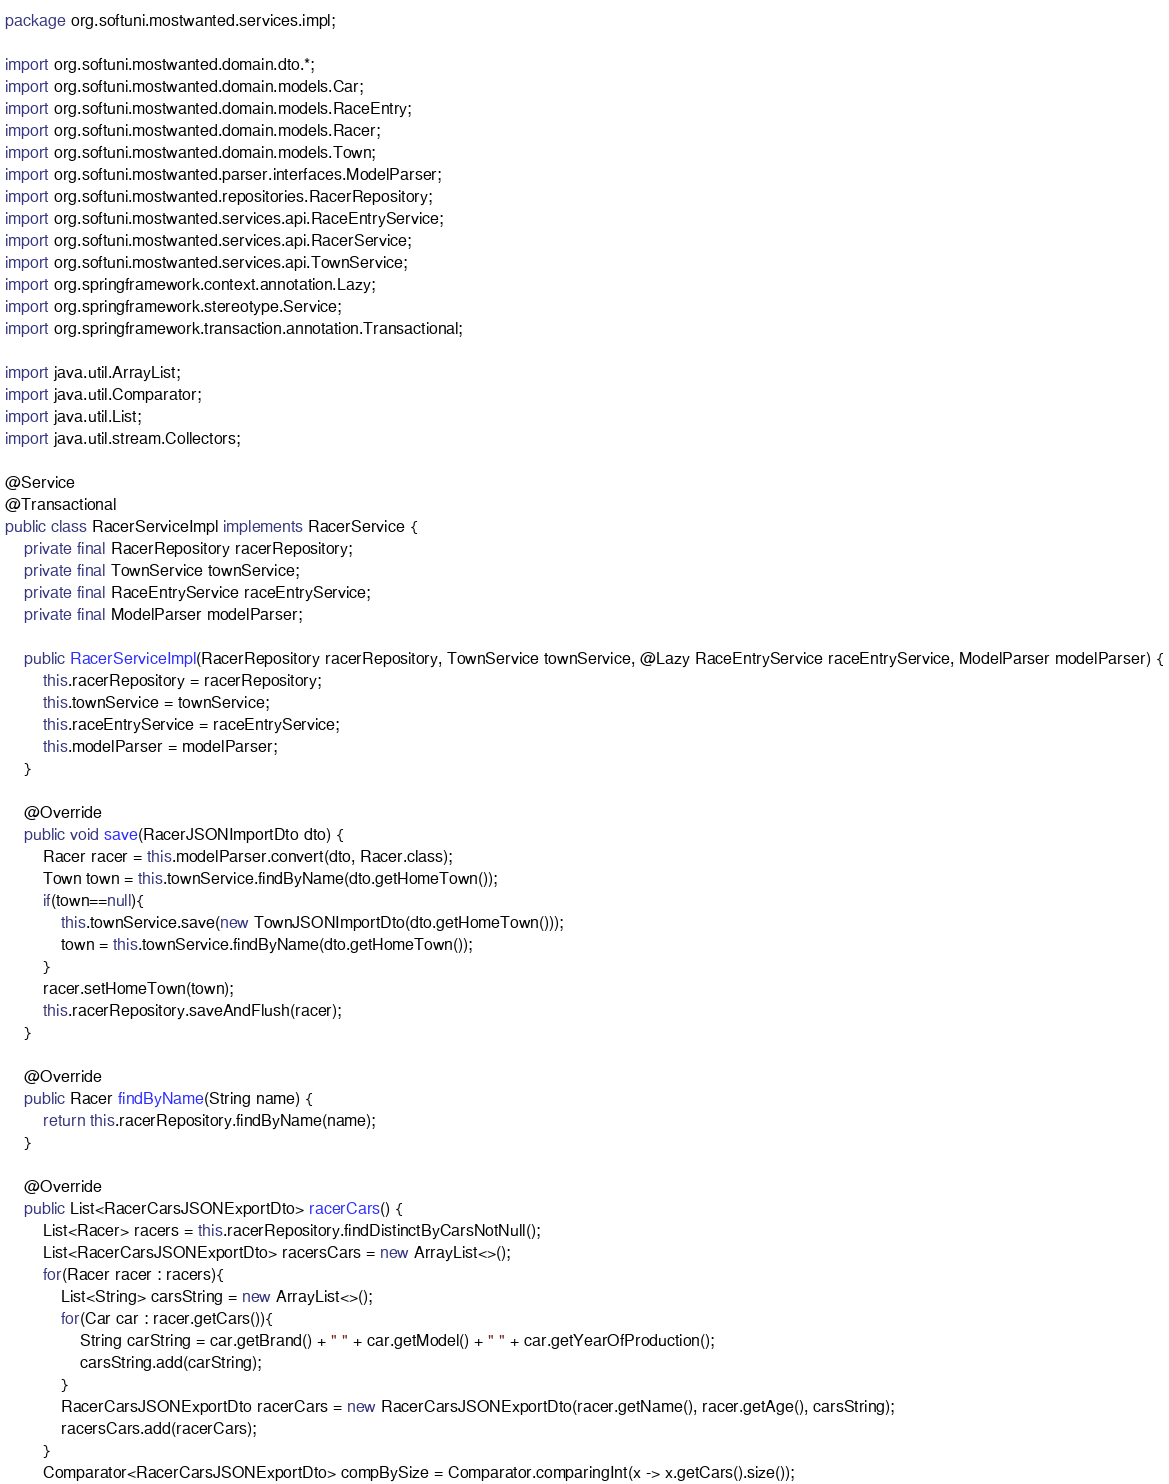<code> <loc_0><loc_0><loc_500><loc_500><_Java_>package org.softuni.mostwanted.services.impl;

import org.softuni.mostwanted.domain.dto.*;
import org.softuni.mostwanted.domain.models.Car;
import org.softuni.mostwanted.domain.models.RaceEntry;
import org.softuni.mostwanted.domain.models.Racer;
import org.softuni.mostwanted.domain.models.Town;
import org.softuni.mostwanted.parser.interfaces.ModelParser;
import org.softuni.mostwanted.repositories.RacerRepository;
import org.softuni.mostwanted.services.api.RaceEntryService;
import org.softuni.mostwanted.services.api.RacerService;
import org.softuni.mostwanted.services.api.TownService;
import org.springframework.context.annotation.Lazy;
import org.springframework.stereotype.Service;
import org.springframework.transaction.annotation.Transactional;

import java.util.ArrayList;
import java.util.Comparator;
import java.util.List;
import java.util.stream.Collectors;

@Service
@Transactional
public class RacerServiceImpl implements RacerService {
    private final RacerRepository racerRepository;
    private final TownService townService;
    private final RaceEntryService raceEntryService;
    private final ModelParser modelParser;

    public RacerServiceImpl(RacerRepository racerRepository, TownService townService, @Lazy RaceEntryService raceEntryService, ModelParser modelParser) {
        this.racerRepository = racerRepository;
        this.townService = townService;
        this.raceEntryService = raceEntryService;
        this.modelParser = modelParser;
    }

    @Override
    public void save(RacerJSONImportDto dto) {
        Racer racer = this.modelParser.convert(dto, Racer.class);
        Town town = this.townService.findByName(dto.getHomeTown());
        if(town==null){
            this.townService.save(new TownJSONImportDto(dto.getHomeTown()));
            town = this.townService.findByName(dto.getHomeTown());
        }
        racer.setHomeTown(town);
        this.racerRepository.saveAndFlush(racer);
    }

    @Override
    public Racer findByName(String name) {
        return this.racerRepository.findByName(name);
    }

    @Override
    public List<RacerCarsJSONExportDto> racerCars() {
        List<Racer> racers = this.racerRepository.findDistinctByCarsNotNull();
        List<RacerCarsJSONExportDto> racersCars = new ArrayList<>();
        for(Racer racer : racers){
            List<String> carsString = new ArrayList<>();
            for(Car car : racer.getCars()){
                String carString = car.getBrand() + " " + car.getModel() + " " + car.getYearOfProduction();
                carsString.add(carString);
            }
            RacerCarsJSONExportDto racerCars = new RacerCarsJSONExportDto(racer.getName(), racer.getAge(), carsString);
            racersCars.add(racerCars);
        }
        Comparator<RacerCarsJSONExportDto> compBySize = Comparator.comparingInt(x -> x.getCars().size());</code> 